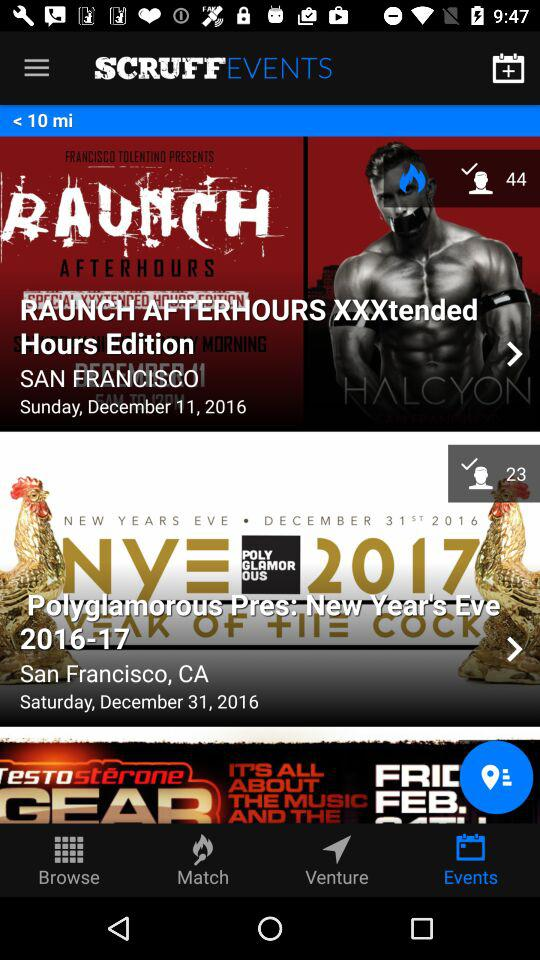What is the date of "RAUNCH AFTERHOURS XXXtended Hours Edition"? The date is Sunday, December 11, 2016. 